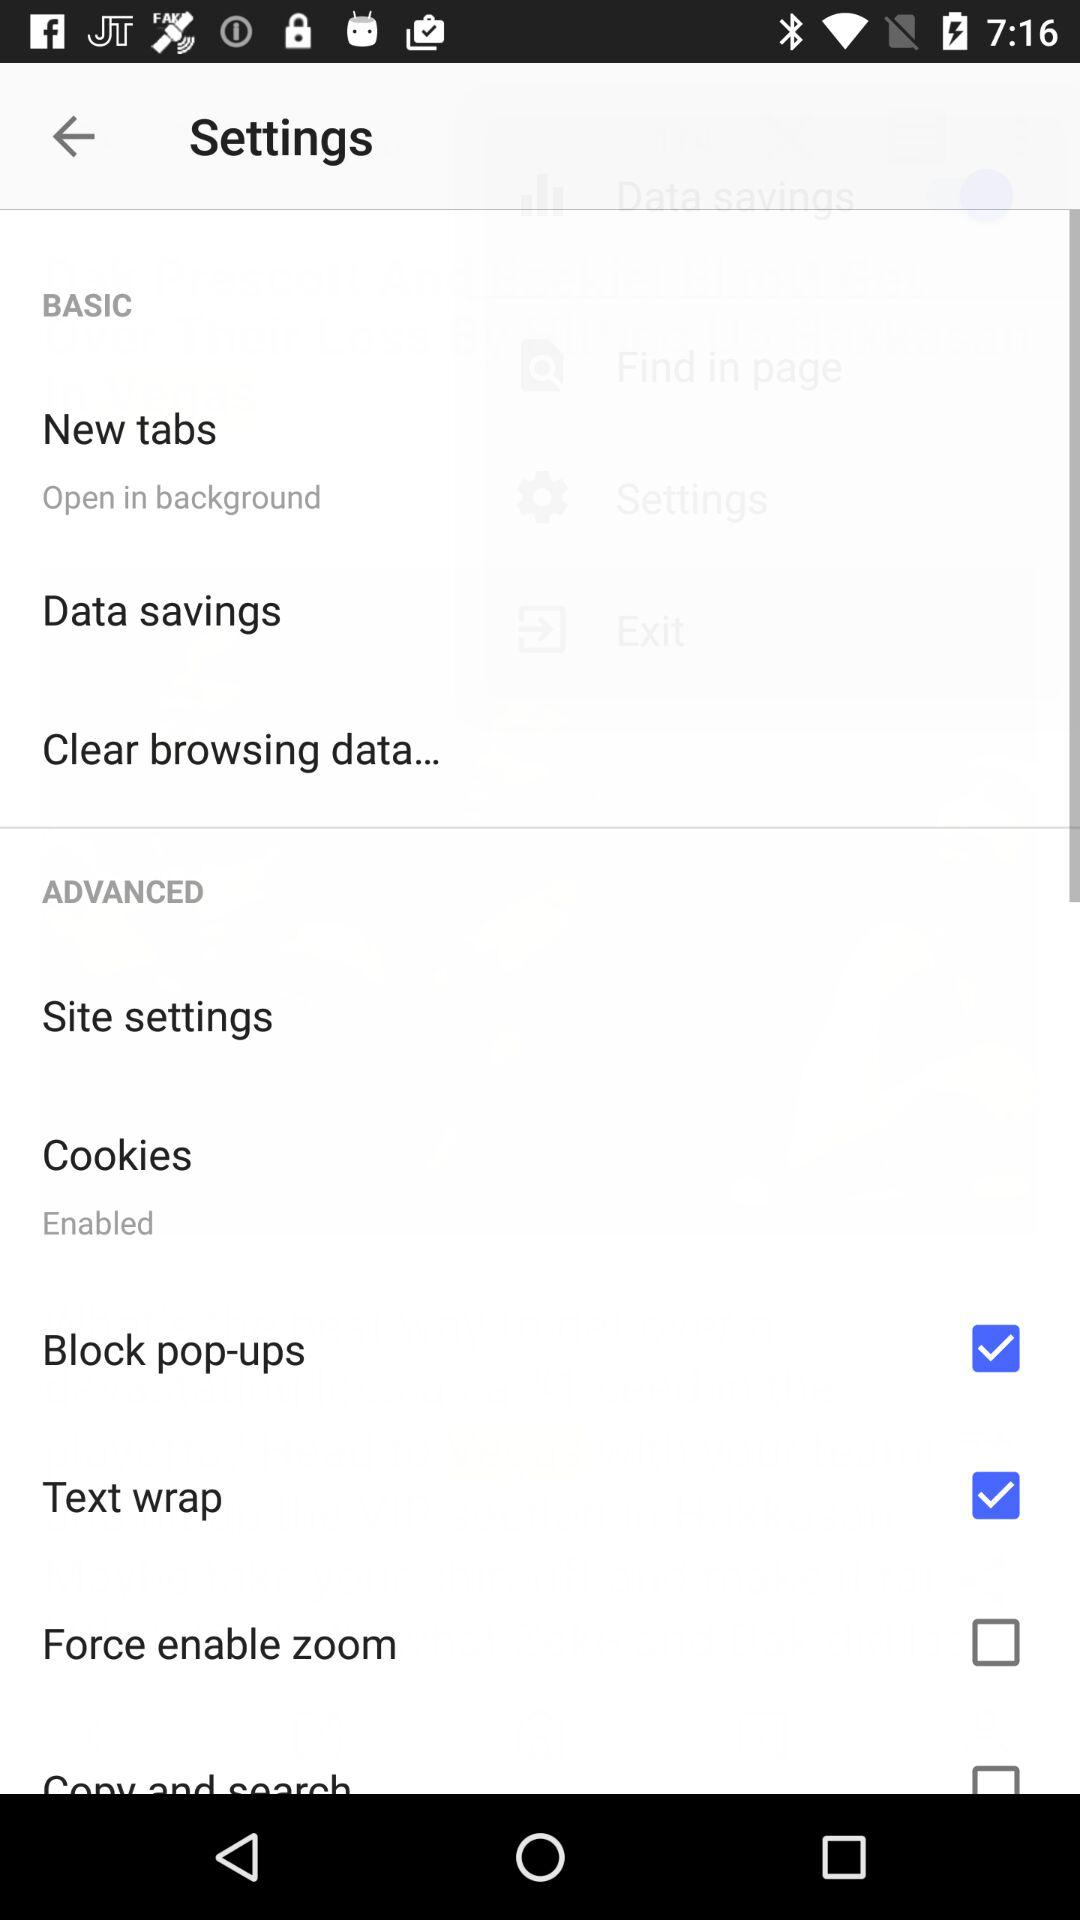What is the status of "Block pop-ups"? The status is "on". 